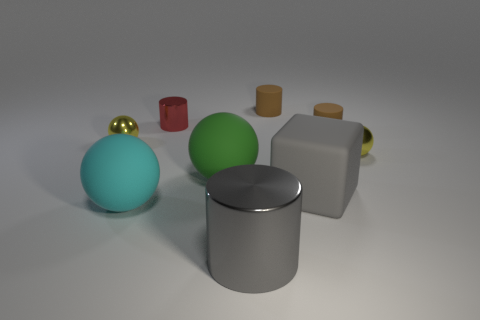Subtract all green rubber spheres. How many spheres are left? 3 Subtract 1 balls. How many balls are left? 3 Add 1 brown matte things. How many objects exist? 10 Subtract all cylinders. How many objects are left? 5 Subtract all brown cylinders. How many cylinders are left? 2 Subtract 0 gray balls. How many objects are left? 9 Subtract all cyan cubes. Subtract all red cylinders. How many cubes are left? 1 Subtract all yellow blocks. How many blue cylinders are left? 0 Subtract all brown cylinders. Subtract all brown rubber cylinders. How many objects are left? 5 Add 2 big gray cubes. How many big gray cubes are left? 3 